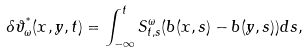Convert formula to latex. <formula><loc_0><loc_0><loc_500><loc_500>\delta \vartheta ^ { ^ { * } } _ { \omega } ( { x } , { y } , t ) = \int _ { - \infty } ^ { t } S ^ { \omega } _ { t , s } ( b ( { x } , s ) - b ( { y } , s ) ) d s ,</formula> 